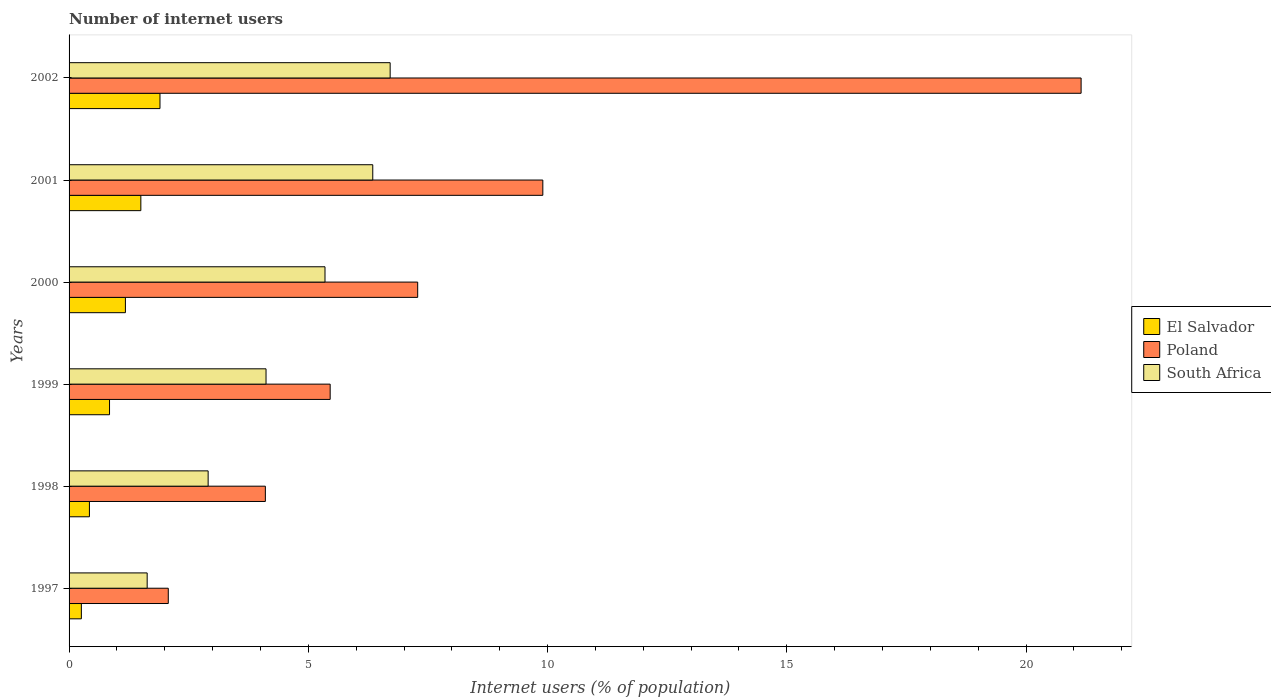How many different coloured bars are there?
Offer a very short reply. 3. In how many cases, is the number of bars for a given year not equal to the number of legend labels?
Offer a very short reply. 0. What is the number of internet users in South Africa in 1998?
Provide a short and direct response. 2.91. Across all years, what is the maximum number of internet users in South Africa?
Make the answer very short. 6.71. Across all years, what is the minimum number of internet users in El Salvador?
Ensure brevity in your answer.  0.26. In which year was the number of internet users in South Africa maximum?
Keep it short and to the point. 2002. In which year was the number of internet users in South Africa minimum?
Your answer should be very brief. 1997. What is the total number of internet users in El Salvador in the graph?
Your answer should be very brief. 6.11. What is the difference between the number of internet users in Poland in 1999 and that in 2001?
Your response must be concise. -4.44. What is the difference between the number of internet users in South Africa in 1998 and the number of internet users in Poland in 1997?
Keep it short and to the point. 0.83. What is the average number of internet users in El Salvador per year?
Your answer should be compact. 1.02. In the year 1998, what is the difference between the number of internet users in South Africa and number of internet users in Poland?
Give a very brief answer. -1.2. What is the ratio of the number of internet users in Poland in 1997 to that in 2000?
Offer a terse response. 0.28. Is the difference between the number of internet users in South Africa in 1999 and 2001 greater than the difference between the number of internet users in Poland in 1999 and 2001?
Give a very brief answer. Yes. What is the difference between the highest and the second highest number of internet users in Poland?
Provide a short and direct response. 11.25. What is the difference between the highest and the lowest number of internet users in El Salvador?
Make the answer very short. 1.64. In how many years, is the number of internet users in Poland greater than the average number of internet users in Poland taken over all years?
Ensure brevity in your answer.  2. Is the sum of the number of internet users in South Africa in 1997 and 1999 greater than the maximum number of internet users in El Salvador across all years?
Make the answer very short. Yes. What does the 1st bar from the top in 1998 represents?
Keep it short and to the point. South Africa. What does the 3rd bar from the bottom in 2001 represents?
Give a very brief answer. South Africa. Are all the bars in the graph horizontal?
Provide a succinct answer. Yes. What is the difference between two consecutive major ticks on the X-axis?
Keep it short and to the point. 5. Are the values on the major ticks of X-axis written in scientific E-notation?
Give a very brief answer. No. Does the graph contain any zero values?
Keep it short and to the point. No. How are the legend labels stacked?
Make the answer very short. Vertical. What is the title of the graph?
Offer a terse response. Number of internet users. What is the label or title of the X-axis?
Offer a terse response. Internet users (% of population). What is the Internet users (% of population) of El Salvador in 1997?
Ensure brevity in your answer.  0.26. What is the Internet users (% of population) of Poland in 1997?
Make the answer very short. 2.07. What is the Internet users (% of population) in South Africa in 1997?
Give a very brief answer. 1.63. What is the Internet users (% of population) of El Salvador in 1998?
Offer a very short reply. 0.43. What is the Internet users (% of population) in Poland in 1998?
Your answer should be compact. 4.1. What is the Internet users (% of population) in South Africa in 1998?
Offer a terse response. 2.91. What is the Internet users (% of population) of El Salvador in 1999?
Provide a short and direct response. 0.85. What is the Internet users (% of population) of Poland in 1999?
Offer a terse response. 5.46. What is the Internet users (% of population) of South Africa in 1999?
Provide a short and direct response. 4.12. What is the Internet users (% of population) in El Salvador in 2000?
Your response must be concise. 1.18. What is the Internet users (% of population) of Poland in 2000?
Make the answer very short. 7.29. What is the Internet users (% of population) of South Africa in 2000?
Offer a very short reply. 5.35. What is the Internet users (% of population) in El Salvador in 2001?
Keep it short and to the point. 1.5. What is the Internet users (% of population) in Poland in 2001?
Give a very brief answer. 9.9. What is the Internet users (% of population) of South Africa in 2001?
Offer a terse response. 6.35. What is the Internet users (% of population) of El Salvador in 2002?
Ensure brevity in your answer.  1.9. What is the Internet users (% of population) of Poland in 2002?
Give a very brief answer. 21.15. What is the Internet users (% of population) in South Africa in 2002?
Your answer should be compact. 6.71. Across all years, what is the maximum Internet users (% of population) of El Salvador?
Offer a terse response. 1.9. Across all years, what is the maximum Internet users (% of population) of Poland?
Keep it short and to the point. 21.15. Across all years, what is the maximum Internet users (% of population) of South Africa?
Keep it short and to the point. 6.71. Across all years, what is the minimum Internet users (% of population) in El Salvador?
Your answer should be very brief. 0.26. Across all years, what is the minimum Internet users (% of population) in Poland?
Offer a very short reply. 2.07. Across all years, what is the minimum Internet users (% of population) in South Africa?
Give a very brief answer. 1.63. What is the total Internet users (% of population) in El Salvador in the graph?
Your response must be concise. 6.11. What is the total Internet users (% of population) in Poland in the graph?
Give a very brief answer. 49.97. What is the total Internet users (% of population) of South Africa in the graph?
Offer a terse response. 27.06. What is the difference between the Internet users (% of population) of El Salvador in 1997 and that in 1998?
Your answer should be compact. -0.17. What is the difference between the Internet users (% of population) in Poland in 1997 and that in 1998?
Provide a short and direct response. -2.03. What is the difference between the Internet users (% of population) of South Africa in 1997 and that in 1998?
Ensure brevity in your answer.  -1.27. What is the difference between the Internet users (% of population) of El Salvador in 1997 and that in 1999?
Offer a very short reply. -0.59. What is the difference between the Internet users (% of population) of Poland in 1997 and that in 1999?
Ensure brevity in your answer.  -3.38. What is the difference between the Internet users (% of population) in South Africa in 1997 and that in 1999?
Keep it short and to the point. -2.48. What is the difference between the Internet users (% of population) of El Salvador in 1997 and that in 2000?
Ensure brevity in your answer.  -0.92. What is the difference between the Internet users (% of population) in Poland in 1997 and that in 2000?
Keep it short and to the point. -5.21. What is the difference between the Internet users (% of population) of South Africa in 1997 and that in 2000?
Make the answer very short. -3.72. What is the difference between the Internet users (% of population) in El Salvador in 1997 and that in 2001?
Make the answer very short. -1.24. What is the difference between the Internet users (% of population) of Poland in 1997 and that in 2001?
Your answer should be compact. -7.83. What is the difference between the Internet users (% of population) of South Africa in 1997 and that in 2001?
Make the answer very short. -4.71. What is the difference between the Internet users (% of population) of El Salvador in 1997 and that in 2002?
Ensure brevity in your answer.  -1.64. What is the difference between the Internet users (% of population) in Poland in 1997 and that in 2002?
Offer a very short reply. -19.08. What is the difference between the Internet users (% of population) in South Africa in 1997 and that in 2002?
Make the answer very short. -5.08. What is the difference between the Internet users (% of population) in El Salvador in 1998 and that in 1999?
Keep it short and to the point. -0.42. What is the difference between the Internet users (% of population) in Poland in 1998 and that in 1999?
Offer a terse response. -1.35. What is the difference between the Internet users (% of population) in South Africa in 1998 and that in 1999?
Your answer should be very brief. -1.21. What is the difference between the Internet users (% of population) of El Salvador in 1998 and that in 2000?
Provide a short and direct response. -0.75. What is the difference between the Internet users (% of population) of Poland in 1998 and that in 2000?
Your response must be concise. -3.18. What is the difference between the Internet users (% of population) of South Africa in 1998 and that in 2000?
Offer a very short reply. -2.44. What is the difference between the Internet users (% of population) in El Salvador in 1998 and that in 2001?
Your answer should be very brief. -1.07. What is the difference between the Internet users (% of population) in Poland in 1998 and that in 2001?
Provide a succinct answer. -5.8. What is the difference between the Internet users (% of population) in South Africa in 1998 and that in 2001?
Your answer should be very brief. -3.44. What is the difference between the Internet users (% of population) in El Salvador in 1998 and that in 2002?
Make the answer very short. -1.47. What is the difference between the Internet users (% of population) of Poland in 1998 and that in 2002?
Offer a very short reply. -17.05. What is the difference between the Internet users (% of population) in South Africa in 1998 and that in 2002?
Ensure brevity in your answer.  -3.8. What is the difference between the Internet users (% of population) of El Salvador in 1999 and that in 2000?
Ensure brevity in your answer.  -0.33. What is the difference between the Internet users (% of population) in Poland in 1999 and that in 2000?
Give a very brief answer. -1.83. What is the difference between the Internet users (% of population) of South Africa in 1999 and that in 2000?
Give a very brief answer. -1.23. What is the difference between the Internet users (% of population) in El Salvador in 1999 and that in 2001?
Provide a short and direct response. -0.65. What is the difference between the Internet users (% of population) in Poland in 1999 and that in 2001?
Give a very brief answer. -4.44. What is the difference between the Internet users (% of population) in South Africa in 1999 and that in 2001?
Give a very brief answer. -2.23. What is the difference between the Internet users (% of population) in El Salvador in 1999 and that in 2002?
Ensure brevity in your answer.  -1.05. What is the difference between the Internet users (% of population) in Poland in 1999 and that in 2002?
Offer a very short reply. -15.69. What is the difference between the Internet users (% of population) of South Africa in 1999 and that in 2002?
Your answer should be compact. -2.59. What is the difference between the Internet users (% of population) in El Salvador in 2000 and that in 2001?
Give a very brief answer. -0.32. What is the difference between the Internet users (% of population) of Poland in 2000 and that in 2001?
Make the answer very short. -2.62. What is the difference between the Internet users (% of population) of South Africa in 2000 and that in 2001?
Your answer should be compact. -1. What is the difference between the Internet users (% of population) in El Salvador in 2000 and that in 2002?
Your answer should be compact. -0.72. What is the difference between the Internet users (% of population) in Poland in 2000 and that in 2002?
Provide a short and direct response. -13.86. What is the difference between the Internet users (% of population) in South Africa in 2000 and that in 2002?
Offer a terse response. -1.36. What is the difference between the Internet users (% of population) of El Salvador in 2001 and that in 2002?
Your answer should be very brief. -0.4. What is the difference between the Internet users (% of population) in Poland in 2001 and that in 2002?
Ensure brevity in your answer.  -11.25. What is the difference between the Internet users (% of population) in South Africa in 2001 and that in 2002?
Offer a very short reply. -0.36. What is the difference between the Internet users (% of population) of El Salvador in 1997 and the Internet users (% of population) of Poland in 1998?
Your answer should be very brief. -3.85. What is the difference between the Internet users (% of population) of El Salvador in 1997 and the Internet users (% of population) of South Africa in 1998?
Keep it short and to the point. -2.65. What is the difference between the Internet users (% of population) of Poland in 1997 and the Internet users (% of population) of South Africa in 1998?
Keep it short and to the point. -0.83. What is the difference between the Internet users (% of population) in El Salvador in 1997 and the Internet users (% of population) in Poland in 1999?
Keep it short and to the point. -5.2. What is the difference between the Internet users (% of population) in El Salvador in 1997 and the Internet users (% of population) in South Africa in 1999?
Keep it short and to the point. -3.86. What is the difference between the Internet users (% of population) in Poland in 1997 and the Internet users (% of population) in South Africa in 1999?
Your response must be concise. -2.04. What is the difference between the Internet users (% of population) of El Salvador in 1997 and the Internet users (% of population) of Poland in 2000?
Offer a terse response. -7.03. What is the difference between the Internet users (% of population) in El Salvador in 1997 and the Internet users (% of population) in South Africa in 2000?
Make the answer very short. -5.09. What is the difference between the Internet users (% of population) of Poland in 1997 and the Internet users (% of population) of South Africa in 2000?
Your response must be concise. -3.28. What is the difference between the Internet users (% of population) in El Salvador in 1997 and the Internet users (% of population) in Poland in 2001?
Keep it short and to the point. -9.64. What is the difference between the Internet users (% of population) of El Salvador in 1997 and the Internet users (% of population) of South Africa in 2001?
Your answer should be very brief. -6.09. What is the difference between the Internet users (% of population) in Poland in 1997 and the Internet users (% of population) in South Africa in 2001?
Offer a terse response. -4.27. What is the difference between the Internet users (% of population) in El Salvador in 1997 and the Internet users (% of population) in Poland in 2002?
Make the answer very short. -20.89. What is the difference between the Internet users (% of population) in El Salvador in 1997 and the Internet users (% of population) in South Africa in 2002?
Offer a terse response. -6.45. What is the difference between the Internet users (% of population) in Poland in 1997 and the Internet users (% of population) in South Africa in 2002?
Your response must be concise. -4.64. What is the difference between the Internet users (% of population) of El Salvador in 1998 and the Internet users (% of population) of Poland in 1999?
Provide a short and direct response. -5.03. What is the difference between the Internet users (% of population) of El Salvador in 1998 and the Internet users (% of population) of South Africa in 1999?
Make the answer very short. -3.69. What is the difference between the Internet users (% of population) in Poland in 1998 and the Internet users (% of population) in South Africa in 1999?
Provide a succinct answer. -0.01. What is the difference between the Internet users (% of population) in El Salvador in 1998 and the Internet users (% of population) in Poland in 2000?
Offer a very short reply. -6.86. What is the difference between the Internet users (% of population) in El Salvador in 1998 and the Internet users (% of population) in South Africa in 2000?
Ensure brevity in your answer.  -4.92. What is the difference between the Internet users (% of population) of Poland in 1998 and the Internet users (% of population) of South Africa in 2000?
Give a very brief answer. -1.25. What is the difference between the Internet users (% of population) in El Salvador in 1998 and the Internet users (% of population) in Poland in 2001?
Provide a short and direct response. -9.48. What is the difference between the Internet users (% of population) of El Salvador in 1998 and the Internet users (% of population) of South Africa in 2001?
Provide a succinct answer. -5.92. What is the difference between the Internet users (% of population) in Poland in 1998 and the Internet users (% of population) in South Africa in 2001?
Your answer should be compact. -2.24. What is the difference between the Internet users (% of population) in El Salvador in 1998 and the Internet users (% of population) in Poland in 2002?
Your answer should be very brief. -20.72. What is the difference between the Internet users (% of population) of El Salvador in 1998 and the Internet users (% of population) of South Africa in 2002?
Your answer should be compact. -6.29. What is the difference between the Internet users (% of population) in Poland in 1998 and the Internet users (% of population) in South Africa in 2002?
Keep it short and to the point. -2.61. What is the difference between the Internet users (% of population) in El Salvador in 1999 and the Internet users (% of population) in Poland in 2000?
Your answer should be very brief. -6.44. What is the difference between the Internet users (% of population) in El Salvador in 1999 and the Internet users (% of population) in South Africa in 2000?
Make the answer very short. -4.5. What is the difference between the Internet users (% of population) of Poland in 1999 and the Internet users (% of population) of South Africa in 2000?
Ensure brevity in your answer.  0.11. What is the difference between the Internet users (% of population) in El Salvador in 1999 and the Internet users (% of population) in Poland in 2001?
Offer a terse response. -9.06. What is the difference between the Internet users (% of population) in El Salvador in 1999 and the Internet users (% of population) in South Africa in 2001?
Offer a very short reply. -5.5. What is the difference between the Internet users (% of population) of Poland in 1999 and the Internet users (% of population) of South Africa in 2001?
Offer a very short reply. -0.89. What is the difference between the Internet users (% of population) of El Salvador in 1999 and the Internet users (% of population) of Poland in 2002?
Your answer should be compact. -20.3. What is the difference between the Internet users (% of population) in El Salvador in 1999 and the Internet users (% of population) in South Africa in 2002?
Keep it short and to the point. -5.86. What is the difference between the Internet users (% of population) of Poland in 1999 and the Internet users (% of population) of South Africa in 2002?
Your answer should be very brief. -1.25. What is the difference between the Internet users (% of population) in El Salvador in 2000 and the Internet users (% of population) in Poland in 2001?
Keep it short and to the point. -8.72. What is the difference between the Internet users (% of population) of El Salvador in 2000 and the Internet users (% of population) of South Africa in 2001?
Keep it short and to the point. -5.17. What is the difference between the Internet users (% of population) of Poland in 2000 and the Internet users (% of population) of South Africa in 2001?
Offer a terse response. 0.94. What is the difference between the Internet users (% of population) of El Salvador in 2000 and the Internet users (% of population) of Poland in 2002?
Keep it short and to the point. -19.97. What is the difference between the Internet users (% of population) in El Salvador in 2000 and the Internet users (% of population) in South Africa in 2002?
Give a very brief answer. -5.53. What is the difference between the Internet users (% of population) of Poland in 2000 and the Internet users (% of population) of South Africa in 2002?
Your response must be concise. 0.58. What is the difference between the Internet users (% of population) of El Salvador in 2001 and the Internet users (% of population) of Poland in 2002?
Offer a very short reply. -19.65. What is the difference between the Internet users (% of population) of El Salvador in 2001 and the Internet users (% of population) of South Africa in 2002?
Your answer should be very brief. -5.21. What is the difference between the Internet users (% of population) in Poland in 2001 and the Internet users (% of population) in South Africa in 2002?
Provide a succinct answer. 3.19. What is the average Internet users (% of population) of El Salvador per year?
Offer a very short reply. 1.02. What is the average Internet users (% of population) in Poland per year?
Your answer should be compact. 8.33. What is the average Internet users (% of population) of South Africa per year?
Your answer should be very brief. 4.51. In the year 1997, what is the difference between the Internet users (% of population) of El Salvador and Internet users (% of population) of Poland?
Provide a short and direct response. -1.82. In the year 1997, what is the difference between the Internet users (% of population) of El Salvador and Internet users (% of population) of South Africa?
Offer a terse response. -1.38. In the year 1997, what is the difference between the Internet users (% of population) of Poland and Internet users (% of population) of South Africa?
Offer a terse response. 0.44. In the year 1998, what is the difference between the Internet users (% of population) in El Salvador and Internet users (% of population) in Poland?
Provide a short and direct response. -3.68. In the year 1998, what is the difference between the Internet users (% of population) of El Salvador and Internet users (% of population) of South Africa?
Provide a succinct answer. -2.48. In the year 1998, what is the difference between the Internet users (% of population) of Poland and Internet users (% of population) of South Africa?
Offer a very short reply. 1.2. In the year 1999, what is the difference between the Internet users (% of population) of El Salvador and Internet users (% of population) of Poland?
Your answer should be very brief. -4.61. In the year 1999, what is the difference between the Internet users (% of population) of El Salvador and Internet users (% of population) of South Africa?
Keep it short and to the point. -3.27. In the year 1999, what is the difference between the Internet users (% of population) of Poland and Internet users (% of population) of South Africa?
Your answer should be compact. 1.34. In the year 2000, what is the difference between the Internet users (% of population) of El Salvador and Internet users (% of population) of Poland?
Your response must be concise. -6.11. In the year 2000, what is the difference between the Internet users (% of population) of El Salvador and Internet users (% of population) of South Africa?
Provide a short and direct response. -4.17. In the year 2000, what is the difference between the Internet users (% of population) of Poland and Internet users (% of population) of South Africa?
Give a very brief answer. 1.94. In the year 2001, what is the difference between the Internet users (% of population) of El Salvador and Internet users (% of population) of Poland?
Give a very brief answer. -8.4. In the year 2001, what is the difference between the Internet users (% of population) of El Salvador and Internet users (% of population) of South Africa?
Your response must be concise. -4.85. In the year 2001, what is the difference between the Internet users (% of population) in Poland and Internet users (% of population) in South Africa?
Give a very brief answer. 3.55. In the year 2002, what is the difference between the Internet users (% of population) of El Salvador and Internet users (% of population) of Poland?
Offer a very short reply. -19.25. In the year 2002, what is the difference between the Internet users (% of population) in El Salvador and Internet users (% of population) in South Africa?
Keep it short and to the point. -4.81. In the year 2002, what is the difference between the Internet users (% of population) of Poland and Internet users (% of population) of South Africa?
Ensure brevity in your answer.  14.44. What is the ratio of the Internet users (% of population) of El Salvador in 1997 to that in 1998?
Give a very brief answer. 0.6. What is the ratio of the Internet users (% of population) of Poland in 1997 to that in 1998?
Make the answer very short. 0.51. What is the ratio of the Internet users (% of population) of South Africa in 1997 to that in 1998?
Give a very brief answer. 0.56. What is the ratio of the Internet users (% of population) in El Salvador in 1997 to that in 1999?
Your answer should be compact. 0.3. What is the ratio of the Internet users (% of population) in Poland in 1997 to that in 1999?
Give a very brief answer. 0.38. What is the ratio of the Internet users (% of population) in South Africa in 1997 to that in 1999?
Your answer should be compact. 0.4. What is the ratio of the Internet users (% of population) in El Salvador in 1997 to that in 2000?
Your response must be concise. 0.22. What is the ratio of the Internet users (% of population) in Poland in 1997 to that in 2000?
Your answer should be compact. 0.28. What is the ratio of the Internet users (% of population) in South Africa in 1997 to that in 2000?
Your answer should be compact. 0.31. What is the ratio of the Internet users (% of population) of El Salvador in 1997 to that in 2001?
Your answer should be compact. 0.17. What is the ratio of the Internet users (% of population) in Poland in 1997 to that in 2001?
Keep it short and to the point. 0.21. What is the ratio of the Internet users (% of population) in South Africa in 1997 to that in 2001?
Provide a short and direct response. 0.26. What is the ratio of the Internet users (% of population) in El Salvador in 1997 to that in 2002?
Make the answer very short. 0.14. What is the ratio of the Internet users (% of population) of Poland in 1997 to that in 2002?
Your answer should be compact. 0.1. What is the ratio of the Internet users (% of population) of South Africa in 1997 to that in 2002?
Your response must be concise. 0.24. What is the ratio of the Internet users (% of population) of El Salvador in 1998 to that in 1999?
Provide a short and direct response. 0.5. What is the ratio of the Internet users (% of population) in Poland in 1998 to that in 1999?
Give a very brief answer. 0.75. What is the ratio of the Internet users (% of population) in South Africa in 1998 to that in 1999?
Make the answer very short. 0.71. What is the ratio of the Internet users (% of population) of El Salvador in 1998 to that in 2000?
Your answer should be compact. 0.36. What is the ratio of the Internet users (% of population) of Poland in 1998 to that in 2000?
Ensure brevity in your answer.  0.56. What is the ratio of the Internet users (% of population) of South Africa in 1998 to that in 2000?
Your answer should be very brief. 0.54. What is the ratio of the Internet users (% of population) of El Salvador in 1998 to that in 2001?
Provide a short and direct response. 0.28. What is the ratio of the Internet users (% of population) in Poland in 1998 to that in 2001?
Ensure brevity in your answer.  0.41. What is the ratio of the Internet users (% of population) in South Africa in 1998 to that in 2001?
Provide a short and direct response. 0.46. What is the ratio of the Internet users (% of population) in El Salvador in 1998 to that in 2002?
Make the answer very short. 0.22. What is the ratio of the Internet users (% of population) of Poland in 1998 to that in 2002?
Make the answer very short. 0.19. What is the ratio of the Internet users (% of population) of South Africa in 1998 to that in 2002?
Offer a terse response. 0.43. What is the ratio of the Internet users (% of population) in El Salvador in 1999 to that in 2000?
Make the answer very short. 0.72. What is the ratio of the Internet users (% of population) in Poland in 1999 to that in 2000?
Offer a very short reply. 0.75. What is the ratio of the Internet users (% of population) of South Africa in 1999 to that in 2000?
Keep it short and to the point. 0.77. What is the ratio of the Internet users (% of population) in El Salvador in 1999 to that in 2001?
Give a very brief answer. 0.56. What is the ratio of the Internet users (% of population) of Poland in 1999 to that in 2001?
Make the answer very short. 0.55. What is the ratio of the Internet users (% of population) in South Africa in 1999 to that in 2001?
Your answer should be compact. 0.65. What is the ratio of the Internet users (% of population) of El Salvador in 1999 to that in 2002?
Offer a very short reply. 0.45. What is the ratio of the Internet users (% of population) in Poland in 1999 to that in 2002?
Give a very brief answer. 0.26. What is the ratio of the Internet users (% of population) in South Africa in 1999 to that in 2002?
Offer a terse response. 0.61. What is the ratio of the Internet users (% of population) of El Salvador in 2000 to that in 2001?
Your answer should be very brief. 0.78. What is the ratio of the Internet users (% of population) of Poland in 2000 to that in 2001?
Offer a terse response. 0.74. What is the ratio of the Internet users (% of population) in South Africa in 2000 to that in 2001?
Offer a terse response. 0.84. What is the ratio of the Internet users (% of population) in El Salvador in 2000 to that in 2002?
Ensure brevity in your answer.  0.62. What is the ratio of the Internet users (% of population) in Poland in 2000 to that in 2002?
Offer a terse response. 0.34. What is the ratio of the Internet users (% of population) in South Africa in 2000 to that in 2002?
Ensure brevity in your answer.  0.8. What is the ratio of the Internet users (% of population) of El Salvador in 2001 to that in 2002?
Provide a short and direct response. 0.79. What is the ratio of the Internet users (% of population) of Poland in 2001 to that in 2002?
Offer a terse response. 0.47. What is the ratio of the Internet users (% of population) of South Africa in 2001 to that in 2002?
Provide a succinct answer. 0.95. What is the difference between the highest and the second highest Internet users (% of population) of Poland?
Your answer should be compact. 11.25. What is the difference between the highest and the second highest Internet users (% of population) of South Africa?
Make the answer very short. 0.36. What is the difference between the highest and the lowest Internet users (% of population) of El Salvador?
Provide a short and direct response. 1.64. What is the difference between the highest and the lowest Internet users (% of population) in Poland?
Your answer should be very brief. 19.08. What is the difference between the highest and the lowest Internet users (% of population) in South Africa?
Ensure brevity in your answer.  5.08. 